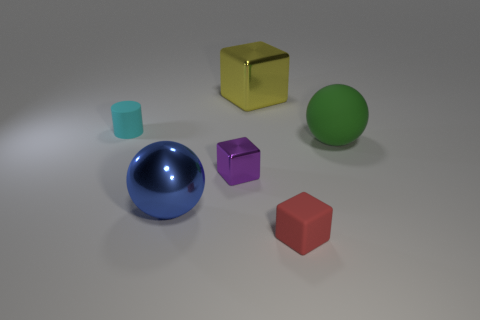Does the green thing have the same shape as the shiny thing that is behind the rubber ball?
Provide a succinct answer. No. What number of objects are either objects on the left side of the blue ball or big balls?
Your response must be concise. 3. Is there any other thing that has the same material as the purple block?
Offer a very short reply. Yes. What number of small matte things are both in front of the small cyan thing and behind the red cube?
Ensure brevity in your answer.  0. What number of things are either tiny cubes behind the blue shiny sphere or large objects that are on the right side of the small purple metallic block?
Provide a short and direct response. 3. What number of other things are there of the same shape as the big matte object?
Offer a terse response. 1. There is a small matte object behind the blue thing; is it the same color as the rubber ball?
Your answer should be compact. No. What number of other things are there of the same size as the blue metal ball?
Your response must be concise. 2. Is the material of the large green sphere the same as the large yellow object?
Your answer should be compact. No. What color is the metal cube in front of the large shiny object behind the green object?
Ensure brevity in your answer.  Purple. 